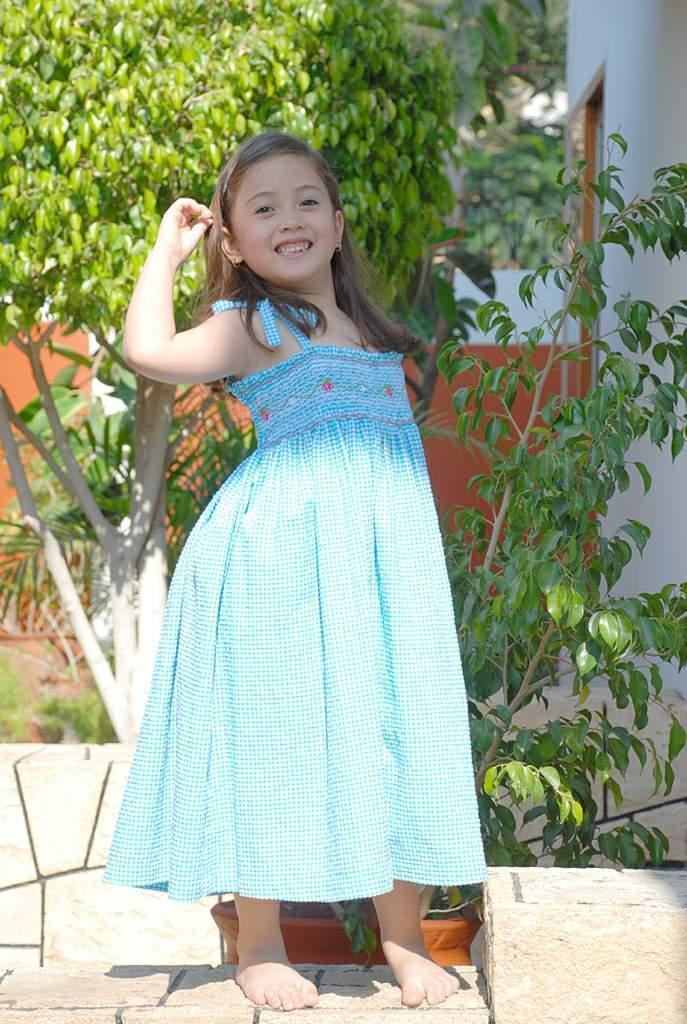Could you give a brief overview of what you see in this image? In this image there is a girl standing on a pavement, in the background there are plants. 